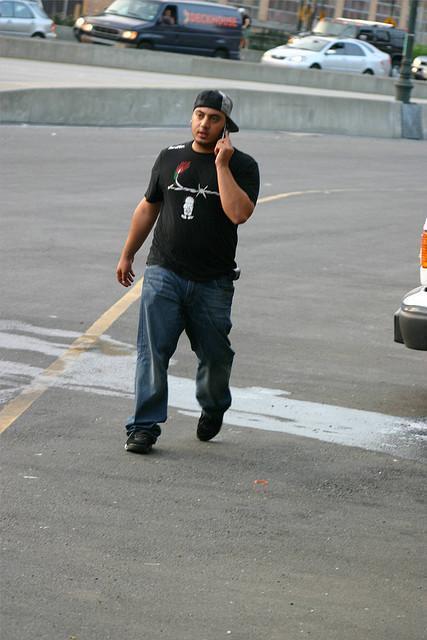How many trucks are there?
Give a very brief answer. 2. 